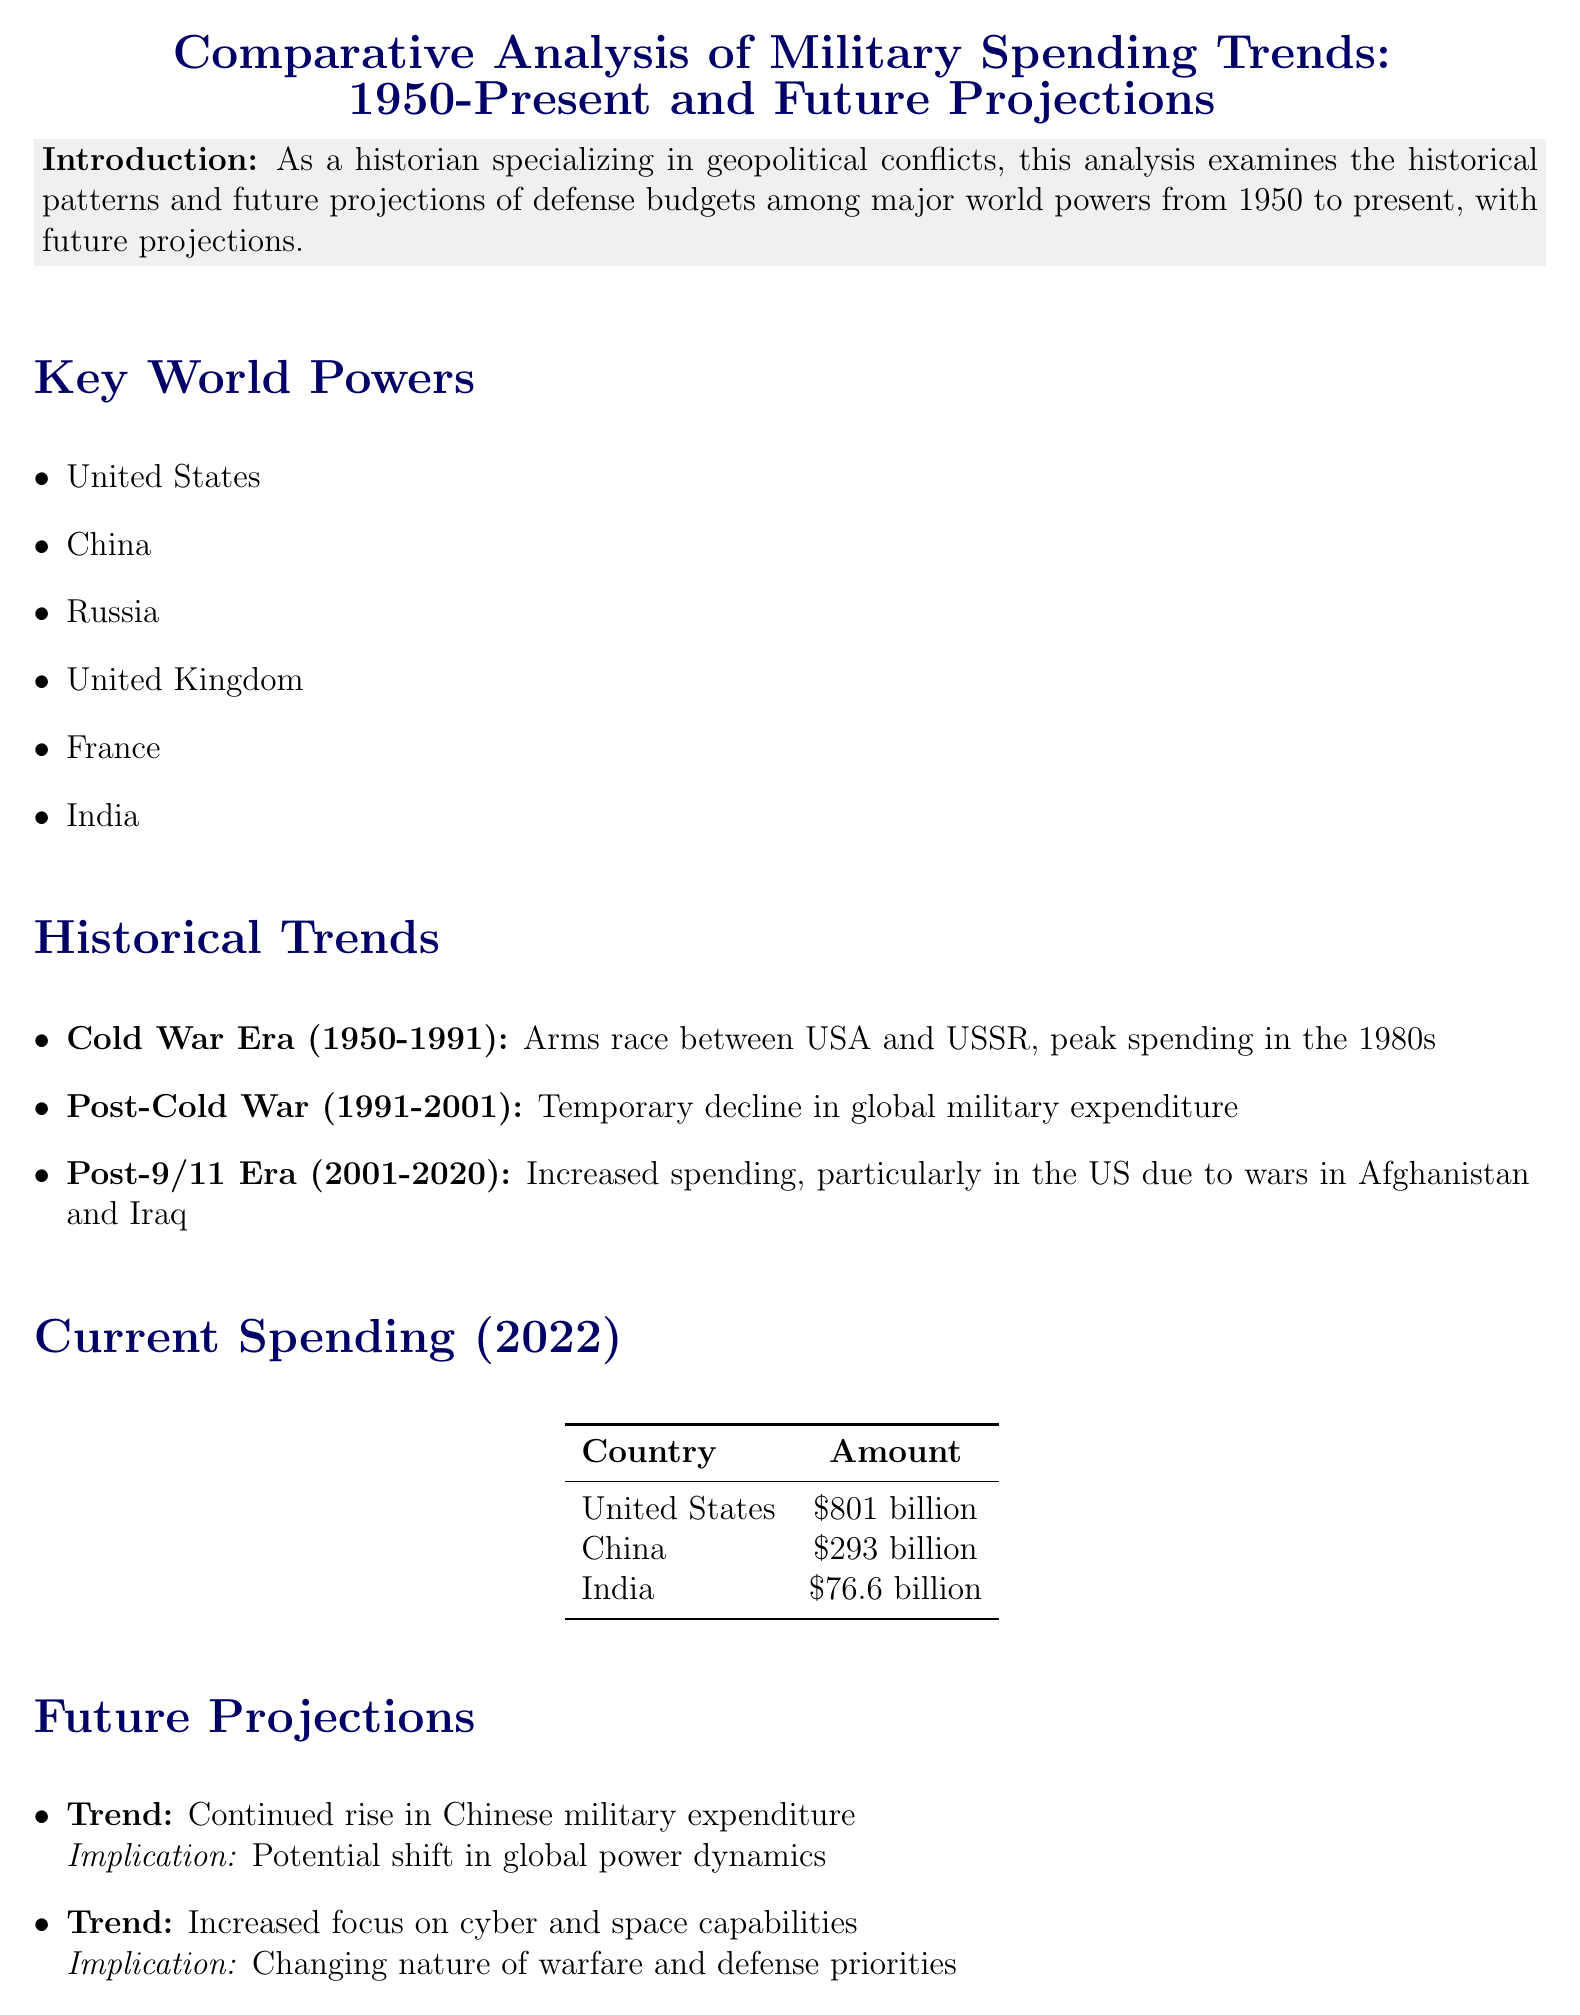What is the focus period of the analysis? The analysis examines military spending trends from 1950 to present, with future projections included.
Answer: 1950 to present Which country had the highest military spending in 2022? The document lists military spending figures for various countries, with the United States having the highest amount.
Answer: United States What was a key highlight during the Cold War Era? The document states that there was an arms race between the USA and USSR, with peak spending occurring in the 1980s.
Answer: Arms race between USA and USSR What is the projected trend for Chinese military expenditure? The document indicates that there is a continued rise in Chinese military expenditure expected in the future.
Answer: Continued rise in Chinese military expenditure How much did India spend on military in 2022? The specific military spending of India in 2022 is outlined in the table, indicating its expenditure.
Answer: 76.6 billion What is a significant future implication of increased focus on cyber and space capabilities? The document suggests that this implies a changing nature of warfare and defense priorities moving forward.
Answer: Changing nature of warfare and defense priorities What period saw a temporary decline in global military expenditure? The analysis details various timeframes, noting a specific period characterized by a decline in spending.
Answer: Post-Cold War (1991-2001) Which economic factors are mentioned as influencing military spending? The document lists multiple factors contributing to military expenditure decisions.
Answer: GDP growth rates, Technological advancements, Geopolitical tensions 